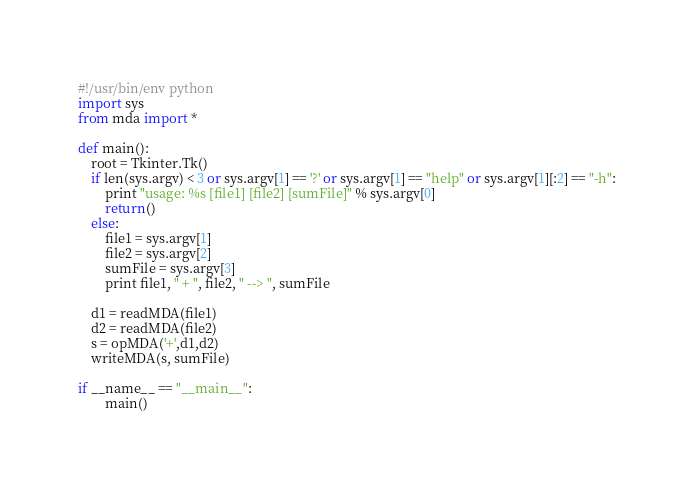<code> <loc_0><loc_0><loc_500><loc_500><_Python_>#!/usr/bin/env python
import sys
from mda import *

def main():
	root = Tkinter.Tk()
	if len(sys.argv) < 3 or sys.argv[1] == '?' or sys.argv[1] == "help" or sys.argv[1][:2] == "-h":
		print "usage: %s [file1] [file2] [sumFile]" % sys.argv[0]
		return()
	else:
		file1 = sys.argv[1]
		file2 = sys.argv[2]
		sumFile = sys.argv[3]
		print file1, " + ", file2, " --> ", sumFile

	d1 = readMDA(file1)
	d2 = readMDA(file2)
	s = opMDA('+',d1,d2)
	writeMDA(s, sumFile)

if __name__ == "__main__":
        main()
</code> 